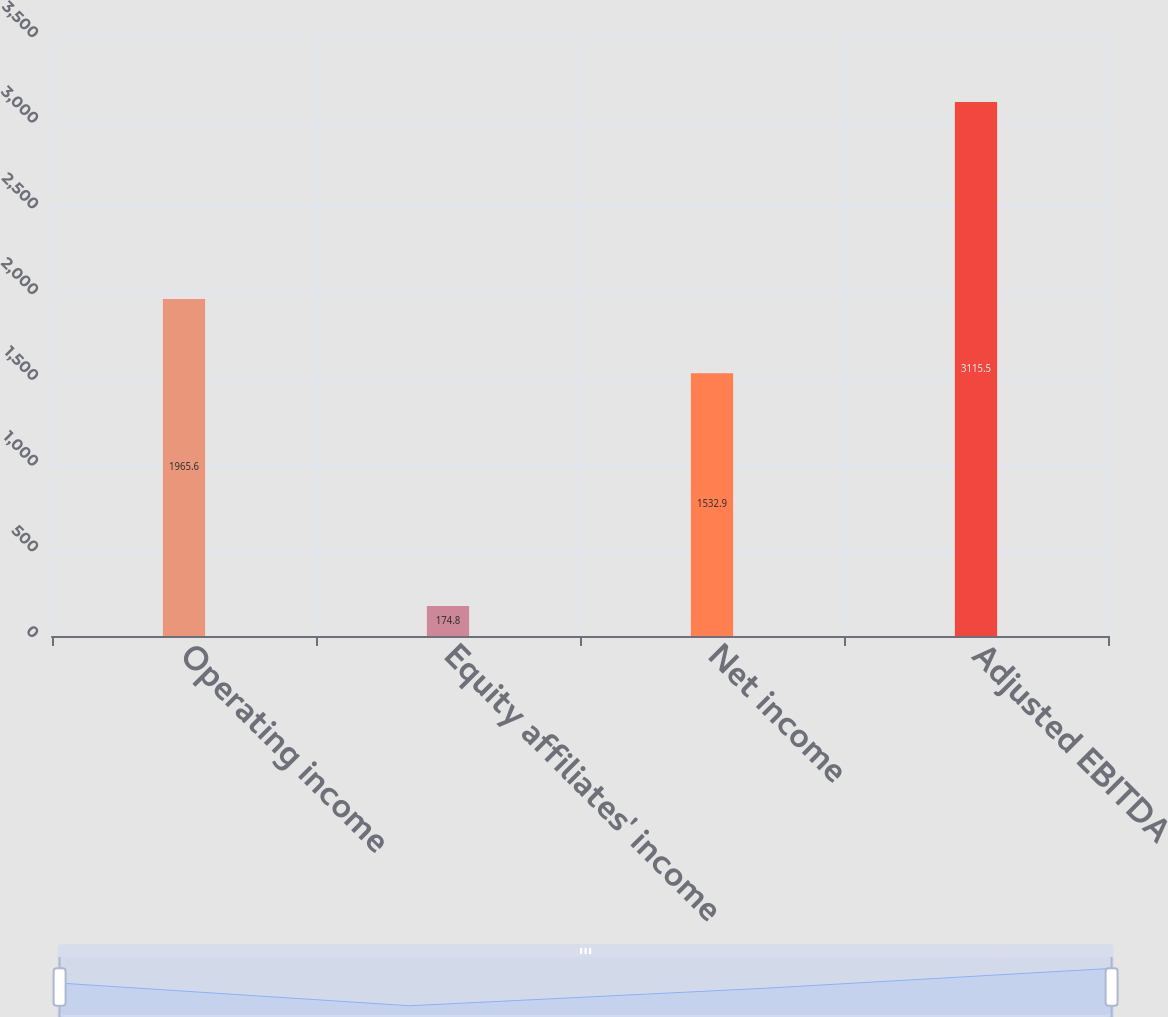Convert chart. <chart><loc_0><loc_0><loc_500><loc_500><bar_chart><fcel>Operating income<fcel>Equity affiliates' income<fcel>Net income<fcel>Adjusted EBITDA<nl><fcel>1965.6<fcel>174.8<fcel>1532.9<fcel>3115.5<nl></chart> 